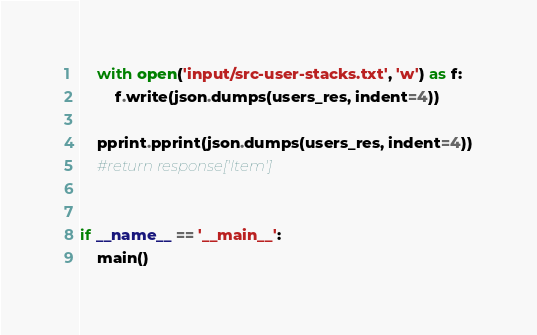Convert code to text. <code><loc_0><loc_0><loc_500><loc_500><_Python_>    with open('input/src-user-stacks.txt', 'w') as f:
        f.write(json.dumps(users_res, indent=4))

    pprint.pprint(json.dumps(users_res, indent=4))
    #return response['Item']


if __name__ == '__main__':
    main()


</code> 